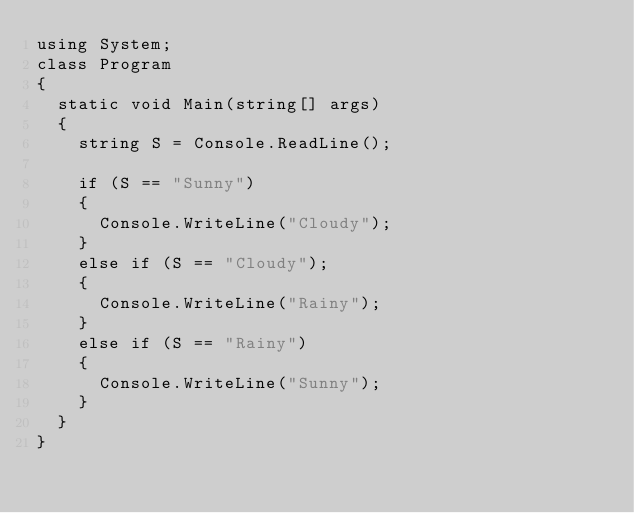Convert code to text. <code><loc_0><loc_0><loc_500><loc_500><_C#_>using System;
class Program
{
  static void Main(string[] args)
  {
    string S = Console.ReadLine();
    
    if (S == "Sunny")
    {
      Console.WriteLine("Cloudy");
    }
    else if (S == "Cloudy");
    {
      Console.WriteLine("Rainy");
    }
    else if (S == "Rainy")
    {
      Console.WriteLine("Sunny");
    }
  }
}</code> 